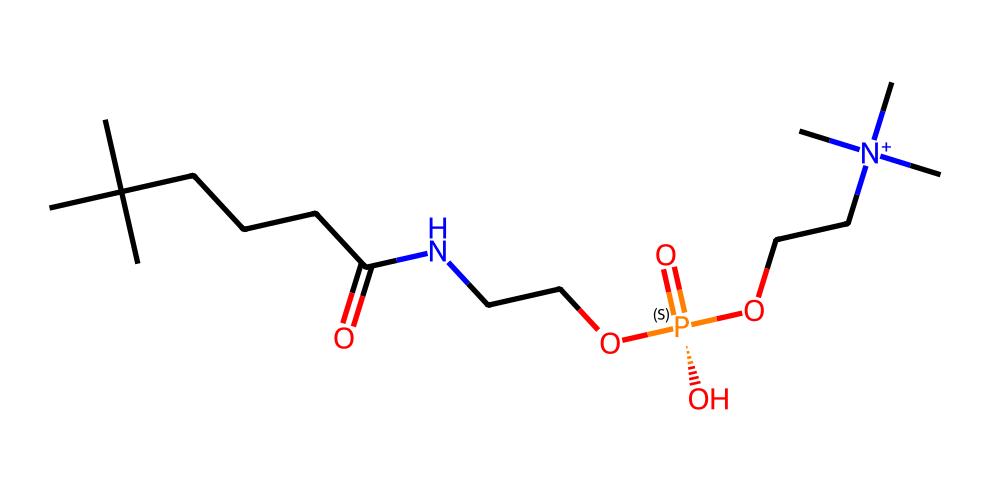What is the backbone structure of this phospholipid? The backbone structure is characterized by a long carbon chain formed by the "CC(C)(C)CCCC" part of the SMILES representation, which indicates a fatty acyl chain.
Answer: carbon chain How many nitrogen atoms are present in the structure? The structure contains two nitrogen atoms, one in "NCC" and one in "[N+]", which are clearly indicated in the SMILES.
Answer: two What kind of chemical group is present at the end of the phospholipid? The chemical group at the end of the phospholipid is a phosphate group, as indicated by the presence of "[P@](=O)(O)O" in the SMILES.
Answer: phosphate group Which part of the molecule is likely responsible for its amphipathic nature? The amphipathic nature of the molecule arises from the hydrophobic hydrocarbon tail (the long carbon chain) and the hydrophilic phosphate group. This dual characteristic is found in the combination of these regions.
Answer: hydrocarbon tail and phosphate group What type of bonding is indicated by "N+" in the structure? The "N+" indicates that there is quaternary ammonium bonding, which involves the nitrogen being positively charged due to having four bonding groups, including one alkyl chain.
Answer: quaternary ammonium 